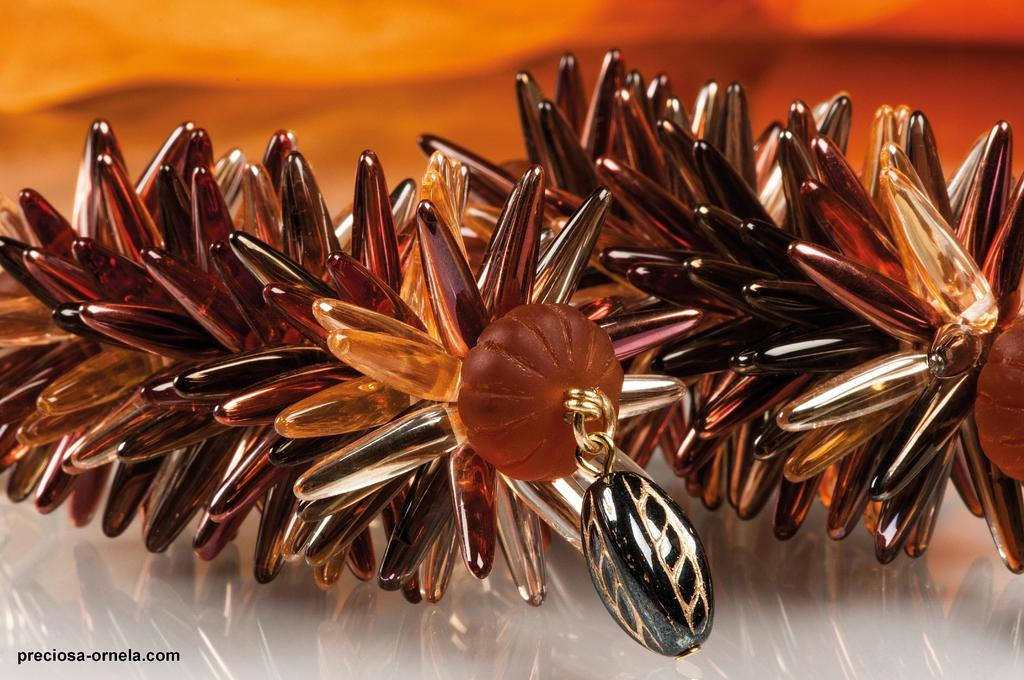What type of accessory is visible in the image? There is a pair of earrings in the image. Where are the earrings placed in the image? The earrings are on an object. Can you describe the background of the image? The background of the image is blurred. Is there any additional information or branding in the image? Yes, there is a watermark in the bottom left corner of the image. How many sheep are visible in the image? There are no sheep present in the image. Is there a cactus growing in the background of the image? There is no cactus visible in the image; the background is blurred. 